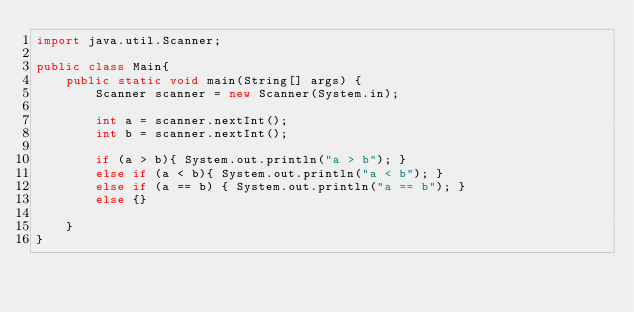<code> <loc_0><loc_0><loc_500><loc_500><_Java_>import java.util.Scanner;

public class Main{
    public static void main(String[] args) {
        Scanner scanner = new Scanner(System.in);
        
        int a = scanner.nextInt();
        int b = scanner.nextInt();
        
        if (a > b){ System.out.println("a > b"); }
        else if (a < b){ System.out.println("a < b"); }
        else if (a == b) { System.out.println("a == b"); }
        else {}
        
    }
}
</code> 